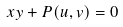<formula> <loc_0><loc_0><loc_500><loc_500>x y + P ( u , v ) = 0</formula> 